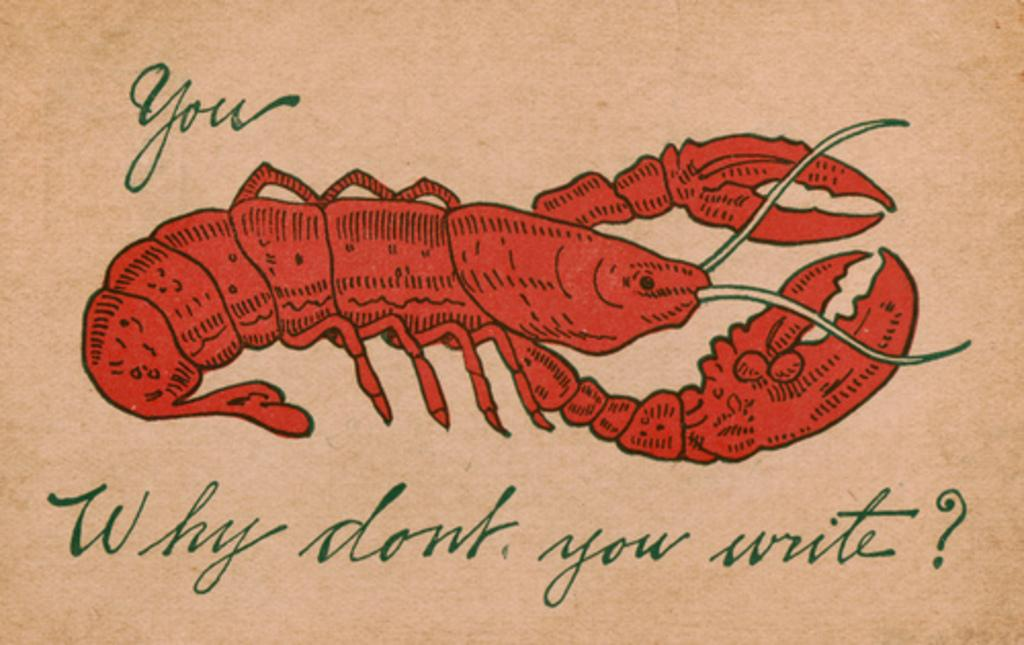What type of animal is in the image? There is a crab in the image. What color is the crab? The crab is red in color. Is the crab depicted realistically or in a stylized manner? The crab is a cartoon. What is written or displayed at the bottom of the image? There is text at the bottom of the image. What type of cable is used to hold the crab in the image? There is no cable present in the image; the crab is a cartoon and not physically held by anything. 